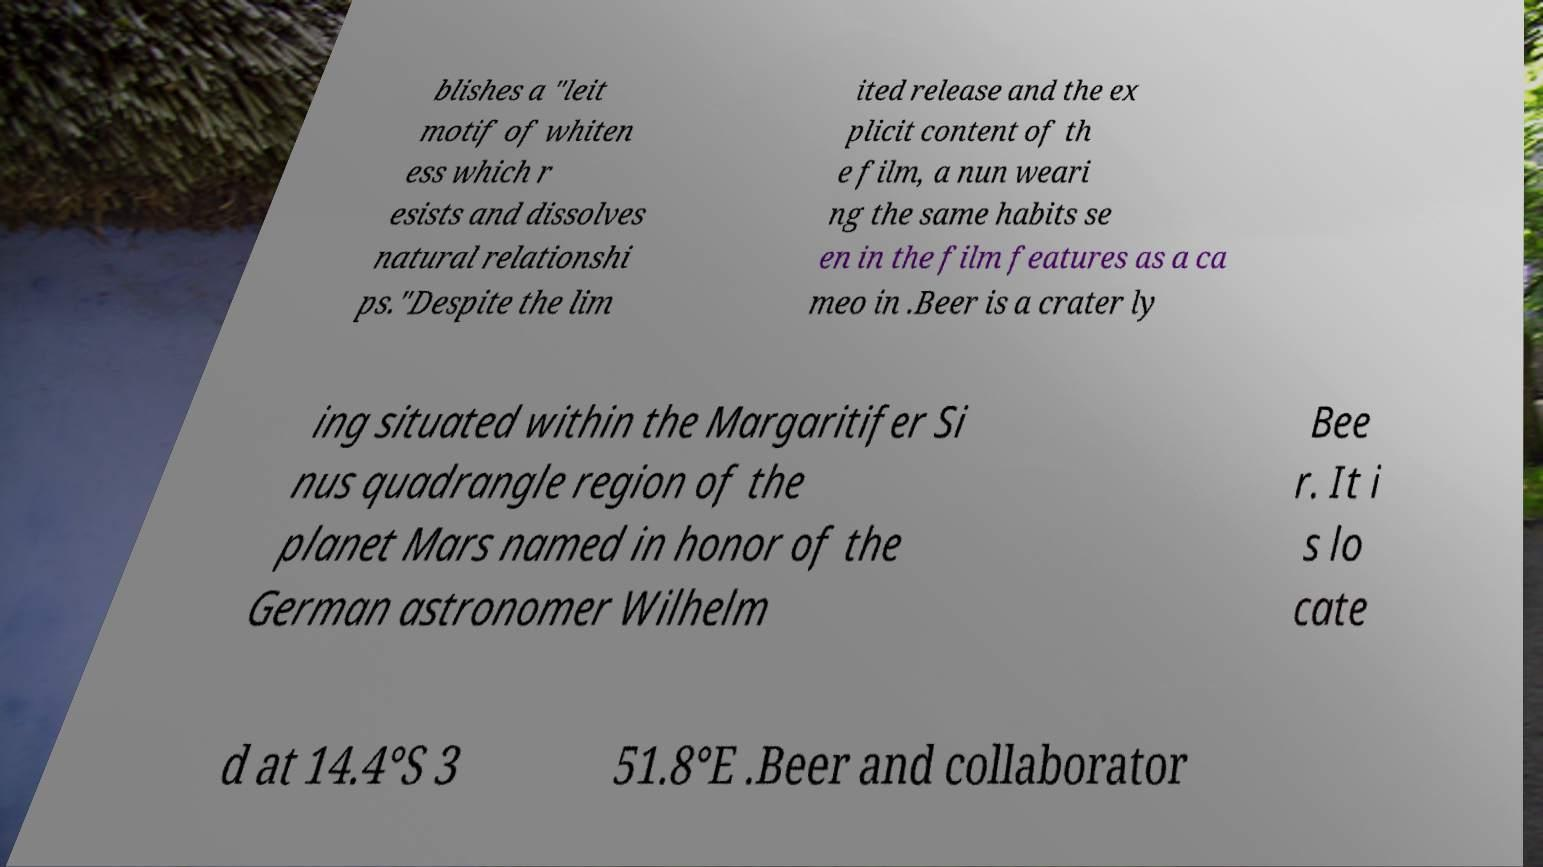Please identify and transcribe the text found in this image. blishes a "leit motif of whiten ess which r esists and dissolves natural relationshi ps."Despite the lim ited release and the ex plicit content of th e film, a nun weari ng the same habits se en in the film features as a ca meo in .Beer is a crater ly ing situated within the Margaritifer Si nus quadrangle region of the planet Mars named in honor of the German astronomer Wilhelm Bee r. It i s lo cate d at 14.4°S 3 51.8°E .Beer and collaborator 